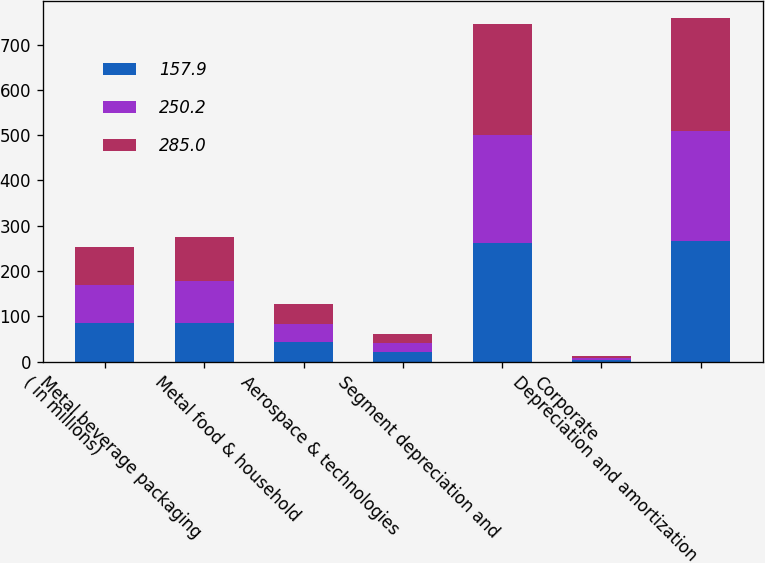Convert chart. <chart><loc_0><loc_0><loc_500><loc_500><stacked_bar_chart><ecel><fcel>( in millions)<fcel>Metal beverage packaging<fcel>Metal food & household<fcel>Aerospace & technologies<fcel>Segment depreciation and<fcel>Corporate<fcel>Depreciation and amortization<nl><fcel>157.9<fcel>84.5<fcel>84.7<fcel>42.5<fcel>21.7<fcel>261.6<fcel>3.9<fcel>265.5<nl><fcel>250.2<fcel>84.5<fcel>93.7<fcel>41.3<fcel>20.2<fcel>238.7<fcel>4.4<fcel>243.1<nl><fcel>285<fcel>84.5<fcel>97.2<fcel>43.8<fcel>19.5<fcel>245<fcel>4.9<fcel>249.9<nl></chart> 